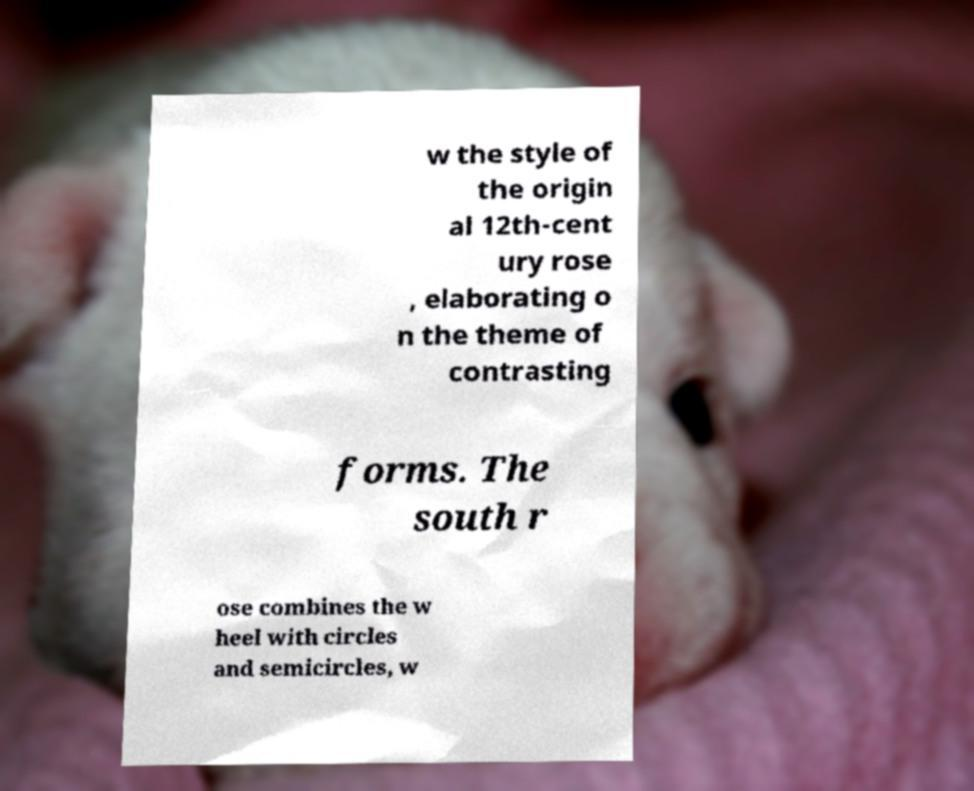For documentation purposes, I need the text within this image transcribed. Could you provide that? w the style of the origin al 12th-cent ury rose , elaborating o n the theme of contrasting forms. The south r ose combines the w heel with circles and semicircles, w 